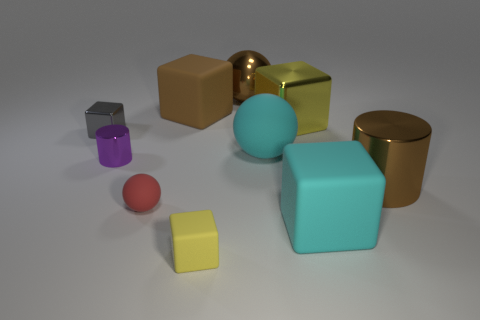Are there more large yellow things than big metal things?
Make the answer very short. No. Are the red sphere and the brown cylinder made of the same material?
Offer a terse response. No. Are there an equal number of big objects that are to the right of the brown shiny ball and tiny objects?
Provide a short and direct response. Yes. What number of small cubes have the same material as the cyan sphere?
Keep it short and to the point. 1. Are there fewer small red matte balls than yellow blocks?
Give a very brief answer. Yes. There is a rubber ball that is behind the tiny red matte ball; does it have the same color as the big metallic ball?
Make the answer very short. No. What number of big spheres are behind the metallic cube left of the cube in front of the cyan block?
Your response must be concise. 1. What number of big cyan rubber cubes are left of the cyan ball?
Your answer should be compact. 0. There is another object that is the same shape as the purple shiny object; what is its color?
Your answer should be very brief. Brown. There is a block that is right of the cyan rubber ball and in front of the purple object; what is it made of?
Provide a succinct answer. Rubber. 